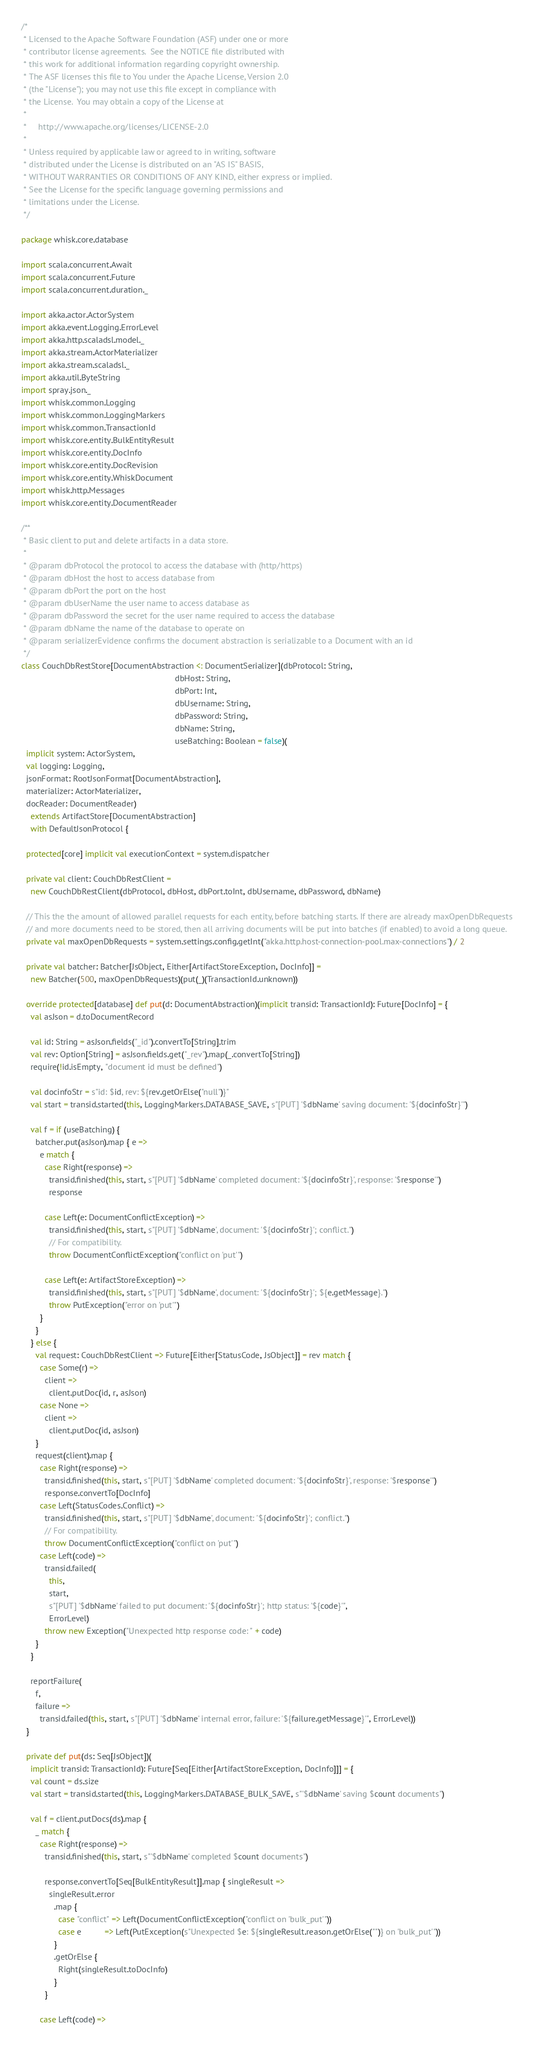Convert code to text. <code><loc_0><loc_0><loc_500><loc_500><_Scala_>/*
 * Licensed to the Apache Software Foundation (ASF) under one or more
 * contributor license agreements.  See the NOTICE file distributed with
 * this work for additional information regarding copyright ownership.
 * The ASF licenses this file to You under the Apache License, Version 2.0
 * (the "License"); you may not use this file except in compliance with
 * the License.  You may obtain a copy of the License at
 *
 *     http://www.apache.org/licenses/LICENSE-2.0
 *
 * Unless required by applicable law or agreed to in writing, software
 * distributed under the License is distributed on an "AS IS" BASIS,
 * WITHOUT WARRANTIES OR CONDITIONS OF ANY KIND, either express or implied.
 * See the License for the specific language governing permissions and
 * limitations under the License.
 */

package whisk.core.database

import scala.concurrent.Await
import scala.concurrent.Future
import scala.concurrent.duration._

import akka.actor.ActorSystem
import akka.event.Logging.ErrorLevel
import akka.http.scaladsl.model._
import akka.stream.ActorMaterializer
import akka.stream.scaladsl._
import akka.util.ByteString
import spray.json._
import whisk.common.Logging
import whisk.common.LoggingMarkers
import whisk.common.TransactionId
import whisk.core.entity.BulkEntityResult
import whisk.core.entity.DocInfo
import whisk.core.entity.DocRevision
import whisk.core.entity.WhiskDocument
import whisk.http.Messages
import whisk.core.entity.DocumentReader

/**
 * Basic client to put and delete artifacts in a data store.
 *
 * @param dbProtocol the protocol to access the database with (http/https)
 * @param dbHost the host to access database from
 * @param dbPort the port on the host
 * @param dbUserName the user name to access database as
 * @param dbPassword the secret for the user name required to access the database
 * @param dbName the name of the database to operate on
 * @param serializerEvidence confirms the document abstraction is serializable to a Document with an id
 */
class CouchDbRestStore[DocumentAbstraction <: DocumentSerializer](dbProtocol: String,
                                                                  dbHost: String,
                                                                  dbPort: Int,
                                                                  dbUsername: String,
                                                                  dbPassword: String,
                                                                  dbName: String,
                                                                  useBatching: Boolean = false)(
  implicit system: ActorSystem,
  val logging: Logging,
  jsonFormat: RootJsonFormat[DocumentAbstraction],
  materializer: ActorMaterializer,
  docReader: DocumentReader)
    extends ArtifactStore[DocumentAbstraction]
    with DefaultJsonProtocol {

  protected[core] implicit val executionContext = system.dispatcher

  private val client: CouchDbRestClient =
    new CouchDbRestClient(dbProtocol, dbHost, dbPort.toInt, dbUsername, dbPassword, dbName)

  // This the the amount of allowed parallel requests for each entity, before batching starts. If there are already maxOpenDbRequests
  // and more documents need to be stored, then all arriving documents will be put into batches (if enabled) to avoid a long queue.
  private val maxOpenDbRequests = system.settings.config.getInt("akka.http.host-connection-pool.max-connections") / 2

  private val batcher: Batcher[JsObject, Either[ArtifactStoreException, DocInfo]] =
    new Batcher(500, maxOpenDbRequests)(put(_)(TransactionId.unknown))

  override protected[database] def put(d: DocumentAbstraction)(implicit transid: TransactionId): Future[DocInfo] = {
    val asJson = d.toDocumentRecord

    val id: String = asJson.fields("_id").convertTo[String].trim
    val rev: Option[String] = asJson.fields.get("_rev").map(_.convertTo[String])
    require(!id.isEmpty, "document id must be defined")

    val docinfoStr = s"id: $id, rev: ${rev.getOrElse("null")}"
    val start = transid.started(this, LoggingMarkers.DATABASE_SAVE, s"[PUT] '$dbName' saving document: '${docinfoStr}'")

    val f = if (useBatching) {
      batcher.put(asJson).map { e =>
        e match {
          case Right(response) =>
            transid.finished(this, start, s"[PUT] '$dbName' completed document: '${docinfoStr}', response: '$response'")
            response

          case Left(e: DocumentConflictException) =>
            transid.finished(this, start, s"[PUT] '$dbName', document: '${docinfoStr}'; conflict.")
            // For compatibility.
            throw DocumentConflictException("conflict on 'put'")

          case Left(e: ArtifactStoreException) =>
            transid.finished(this, start, s"[PUT] '$dbName', document: '${docinfoStr}'; ${e.getMessage}.")
            throw PutException("error on 'put'")
        }
      }
    } else {
      val request: CouchDbRestClient => Future[Either[StatusCode, JsObject]] = rev match {
        case Some(r) =>
          client =>
            client.putDoc(id, r, asJson)
        case None =>
          client =>
            client.putDoc(id, asJson)
      }
      request(client).map {
        case Right(response) =>
          transid.finished(this, start, s"[PUT] '$dbName' completed document: '${docinfoStr}', response: '$response'")
          response.convertTo[DocInfo]
        case Left(StatusCodes.Conflict) =>
          transid.finished(this, start, s"[PUT] '$dbName', document: '${docinfoStr}'; conflict.")
          // For compatibility.
          throw DocumentConflictException("conflict on 'put'")
        case Left(code) =>
          transid.failed(
            this,
            start,
            s"[PUT] '$dbName' failed to put document: '${docinfoStr}'; http status: '${code}'",
            ErrorLevel)
          throw new Exception("Unexpected http response code: " + code)
      }
    }

    reportFailure(
      f,
      failure =>
        transid.failed(this, start, s"[PUT] '$dbName' internal error, failure: '${failure.getMessage}'", ErrorLevel))
  }

  private def put(ds: Seq[JsObject])(
    implicit transid: TransactionId): Future[Seq[Either[ArtifactStoreException, DocInfo]]] = {
    val count = ds.size
    val start = transid.started(this, LoggingMarkers.DATABASE_BULK_SAVE, s"'$dbName' saving $count documents")

    val f = client.putDocs(ds).map {
      _ match {
        case Right(response) =>
          transid.finished(this, start, s"'$dbName' completed $count documents")

          response.convertTo[Seq[BulkEntityResult]].map { singleResult =>
            singleResult.error
              .map {
                case "conflict" => Left(DocumentConflictException("conflict on 'bulk_put'"))
                case e          => Left(PutException(s"Unexpected $e: ${singleResult.reason.getOrElse("")} on 'bulk_put'"))
              }
              .getOrElse {
                Right(singleResult.toDocInfo)
              }
          }

        case Left(code) =></code> 